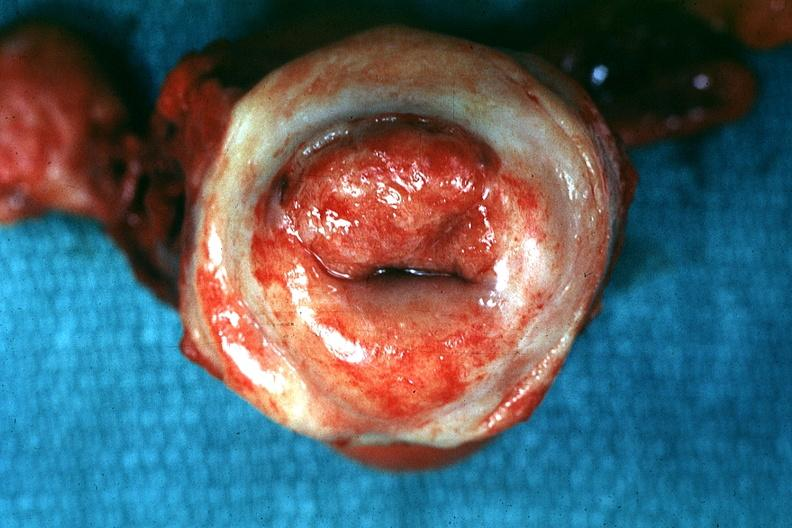what is inflamed exocervix said?
Answer the question using a single word or phrase. To be invasive carcinoma 